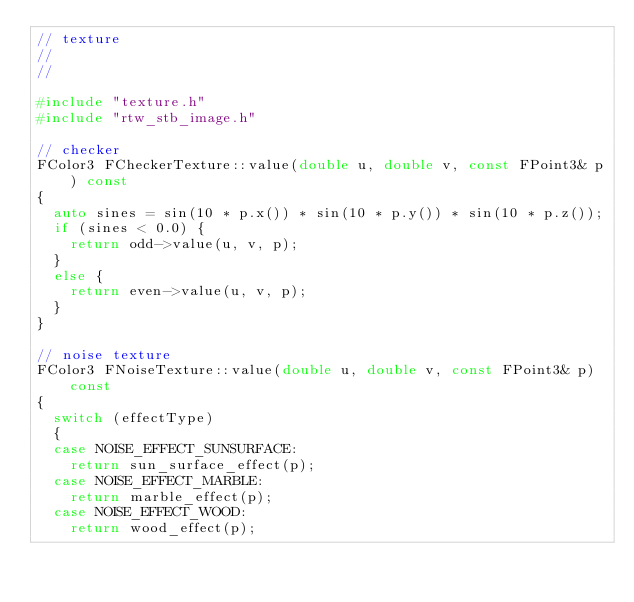<code> <loc_0><loc_0><loc_500><loc_500><_C++_>// texture
//
//

#include "texture.h"
#include "rtw_stb_image.h"

// checker
FColor3 FCheckerTexture::value(double u, double v, const FPoint3& p) const
{
	auto sines = sin(10 * p.x()) * sin(10 * p.y()) * sin(10 * p.z());
	if (sines < 0.0) {
		return odd->value(u, v, p);
	}
	else {
		return even->value(u, v, p);
	}
}

// noise texture
FColor3 FNoiseTexture::value(double u, double v, const FPoint3& p) const
{
	switch (effectType)
	{
	case NOISE_EFFECT_SUNSURFACE:
		return sun_surface_effect(p);
	case NOISE_EFFECT_MARBLE:
		return marble_effect(p);
	case NOISE_EFFECT_WOOD:
		return wood_effect(p);</code> 